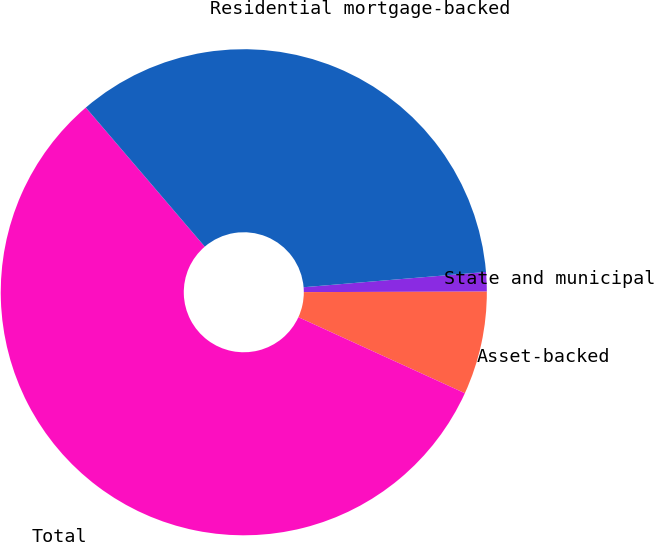Convert chart. <chart><loc_0><loc_0><loc_500><loc_500><pie_chart><fcel>State and municipal<fcel>Asset-backed<fcel>Total<fcel>Residential mortgage-backed<nl><fcel>1.29%<fcel>6.86%<fcel>56.92%<fcel>34.93%<nl></chart> 